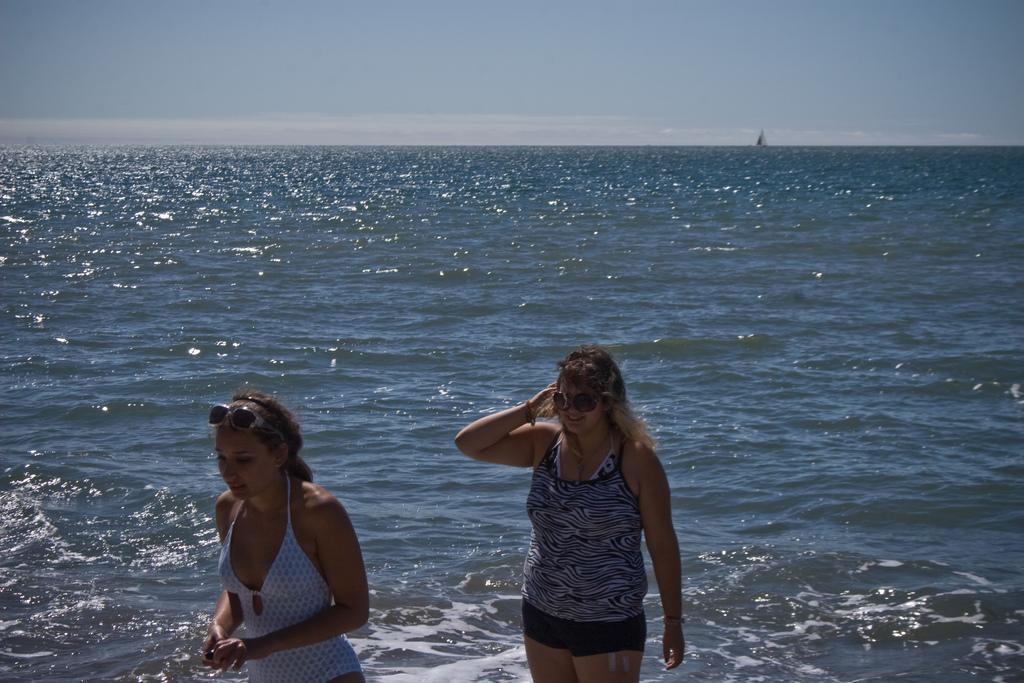In one or two sentences, can you explain what this image depicts? In front of the image there are two people. Behind them there is a boat in the water. In the background of the image there is sky. 